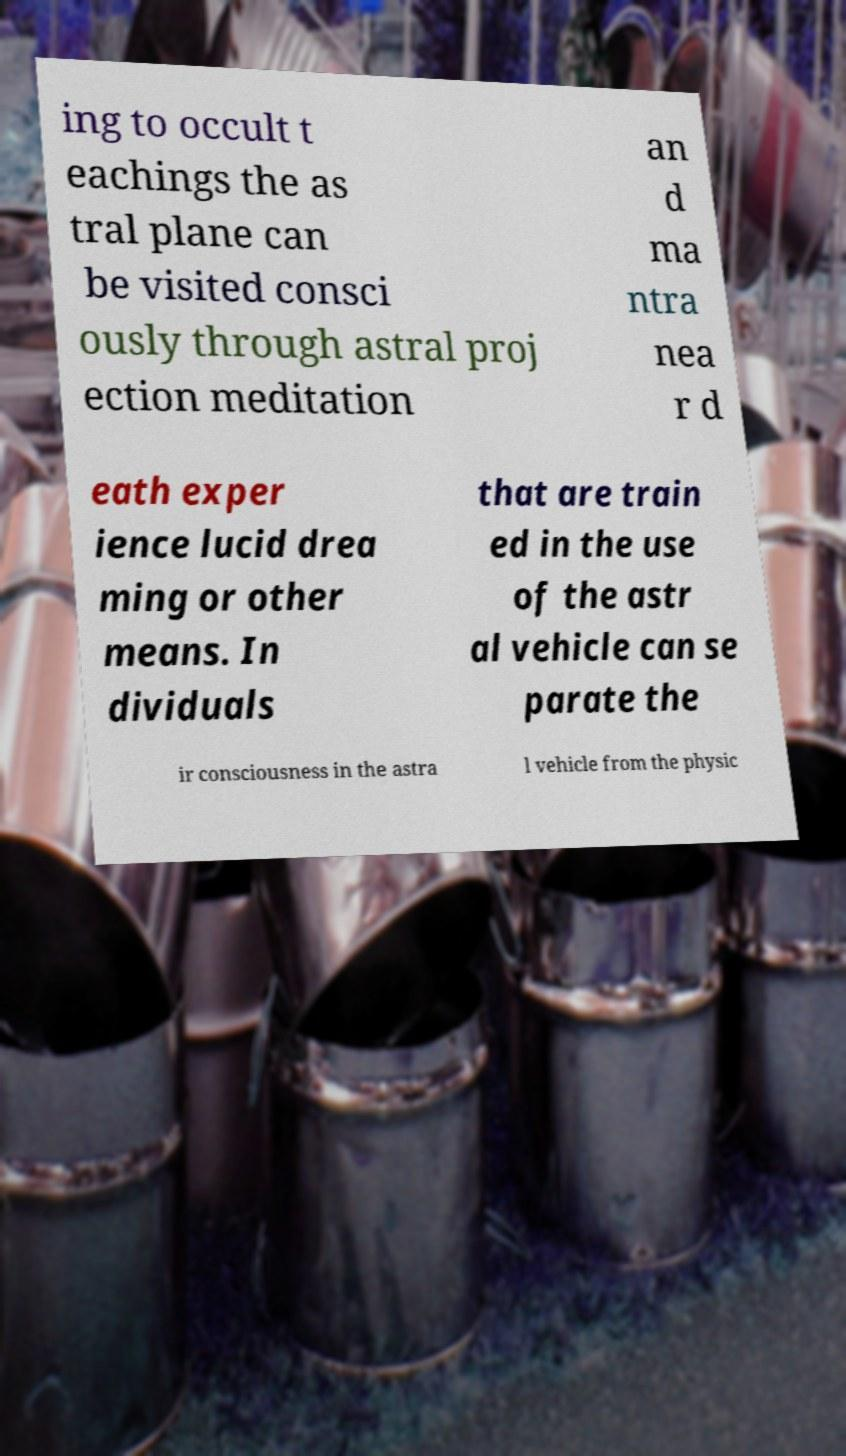Please identify and transcribe the text found in this image. ing to occult t eachings the as tral plane can be visited consci ously through astral proj ection meditation an d ma ntra nea r d eath exper ience lucid drea ming or other means. In dividuals that are train ed in the use of the astr al vehicle can se parate the ir consciousness in the astra l vehicle from the physic 